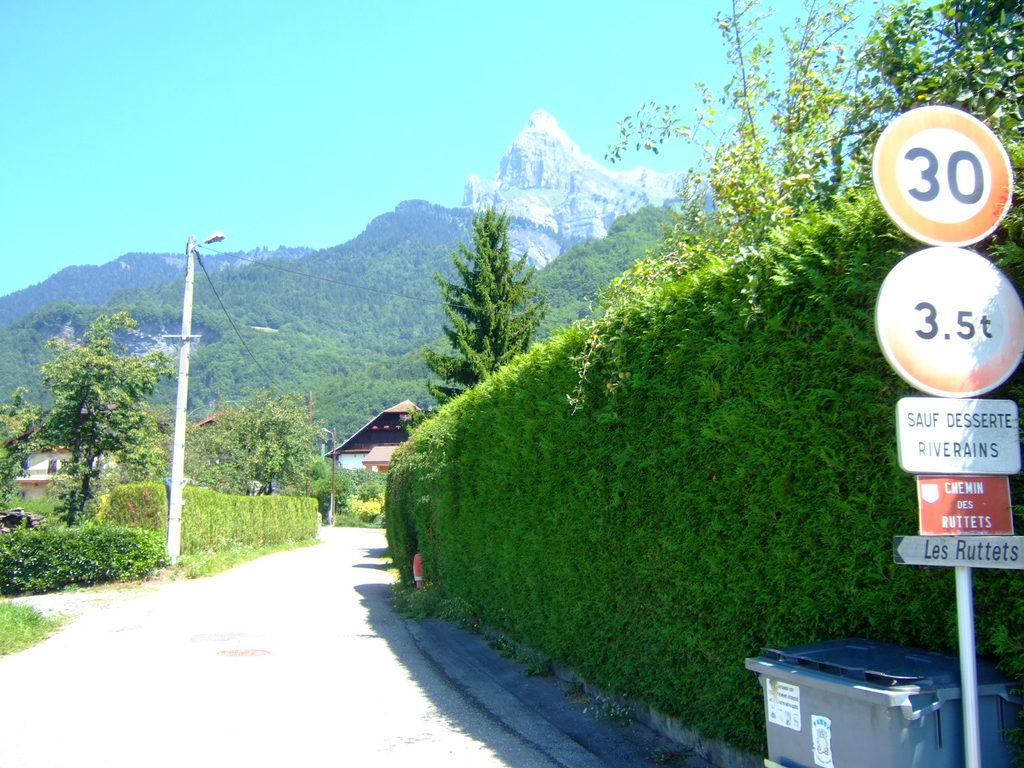<image>
Provide a brief description of the given image. A large shrubbery with a sign that says 30 on it. 